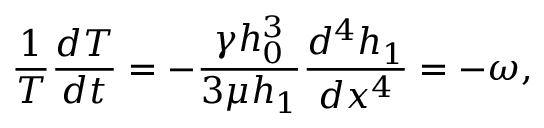<formula> <loc_0><loc_0><loc_500><loc_500>\frac { 1 } { T } \frac { d T } { d t } = - \frac { \gamma h _ { 0 } ^ { 3 } } { 3 \mu h _ { 1 } } \frac { d ^ { 4 } h _ { 1 } } { d x ^ { 4 } } = - \omega ,</formula> 